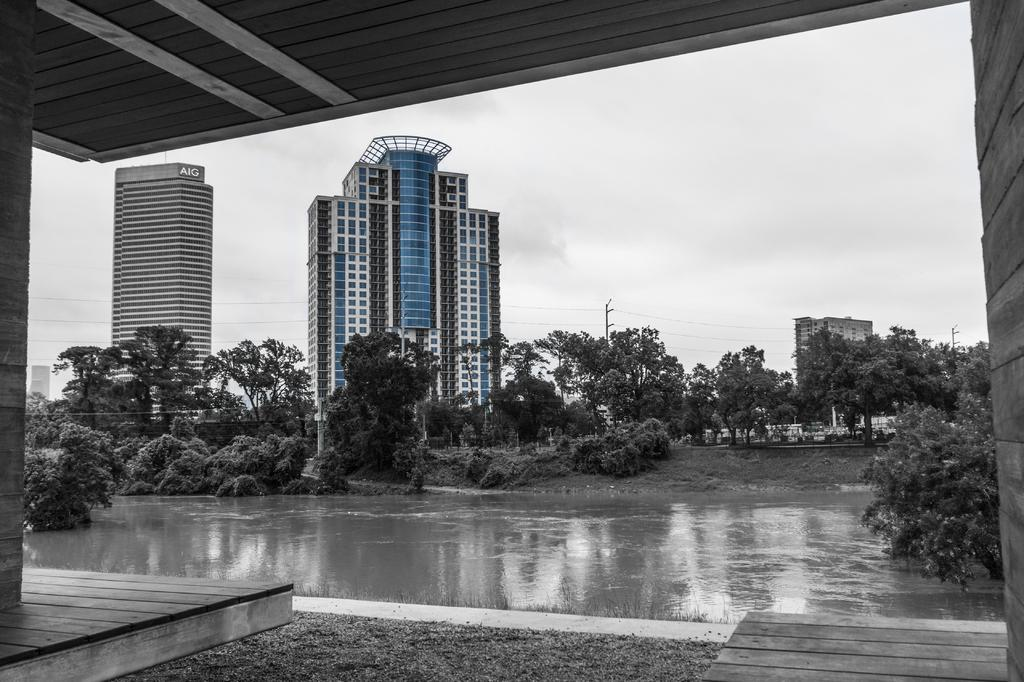What is the primary element in the image? The image consists of water. What can be seen in the front of the image? There are many trees and buildings in the front of the image. What is the surface on which the image is based? There is a floor at the bottom of the image. What is visible in the background of the image? The sky is visible in the background of the image. How would you describe the sky in the background? The sky appears cloudy in the background. What religious symbols can be seen in the image? There are no religious symbols present in the image. Can you describe the eyes of the person in the image? There is no person present in the image, so it is not possible to describe their eyes. 